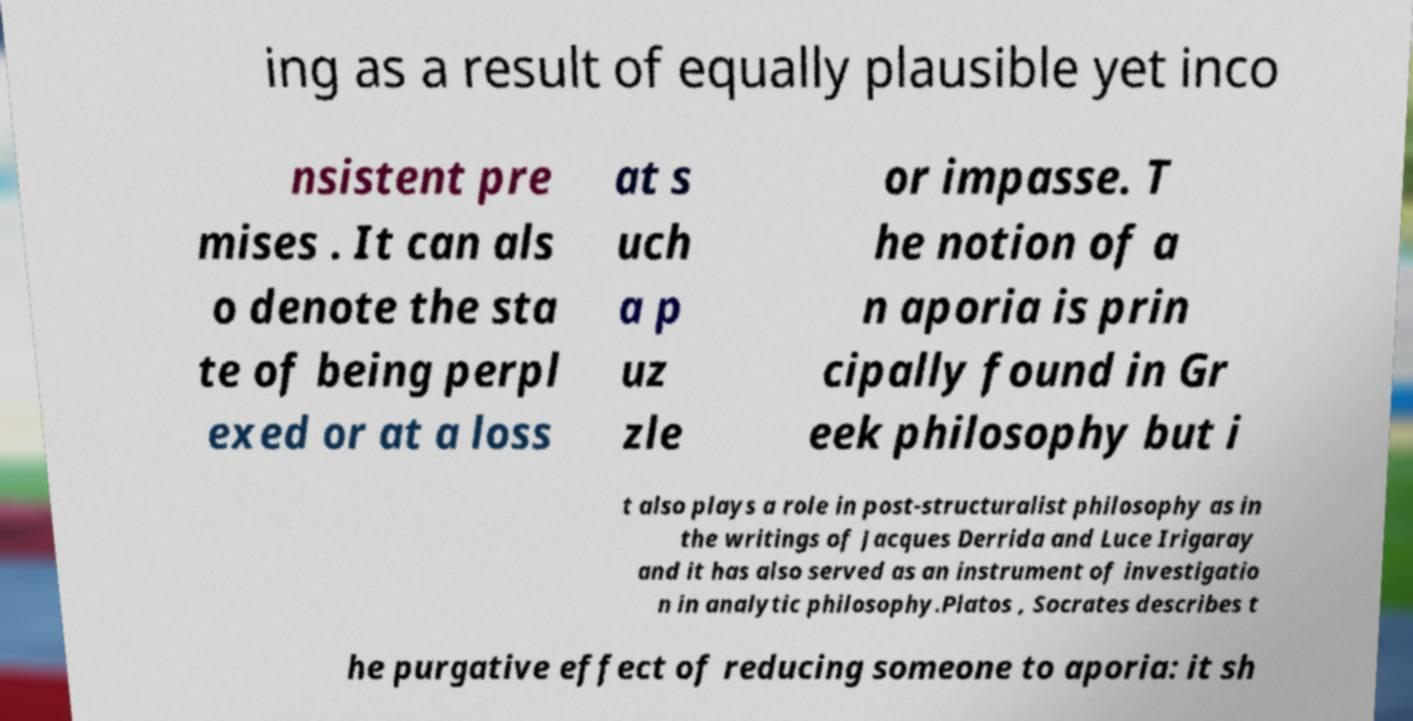There's text embedded in this image that I need extracted. Can you transcribe it verbatim? ing as a result of equally plausible yet inco nsistent pre mises . It can als o denote the sta te of being perpl exed or at a loss at s uch a p uz zle or impasse. T he notion of a n aporia is prin cipally found in Gr eek philosophy but i t also plays a role in post-structuralist philosophy as in the writings of Jacques Derrida and Luce Irigaray and it has also served as an instrument of investigatio n in analytic philosophy.Platos , Socrates describes t he purgative effect of reducing someone to aporia: it sh 